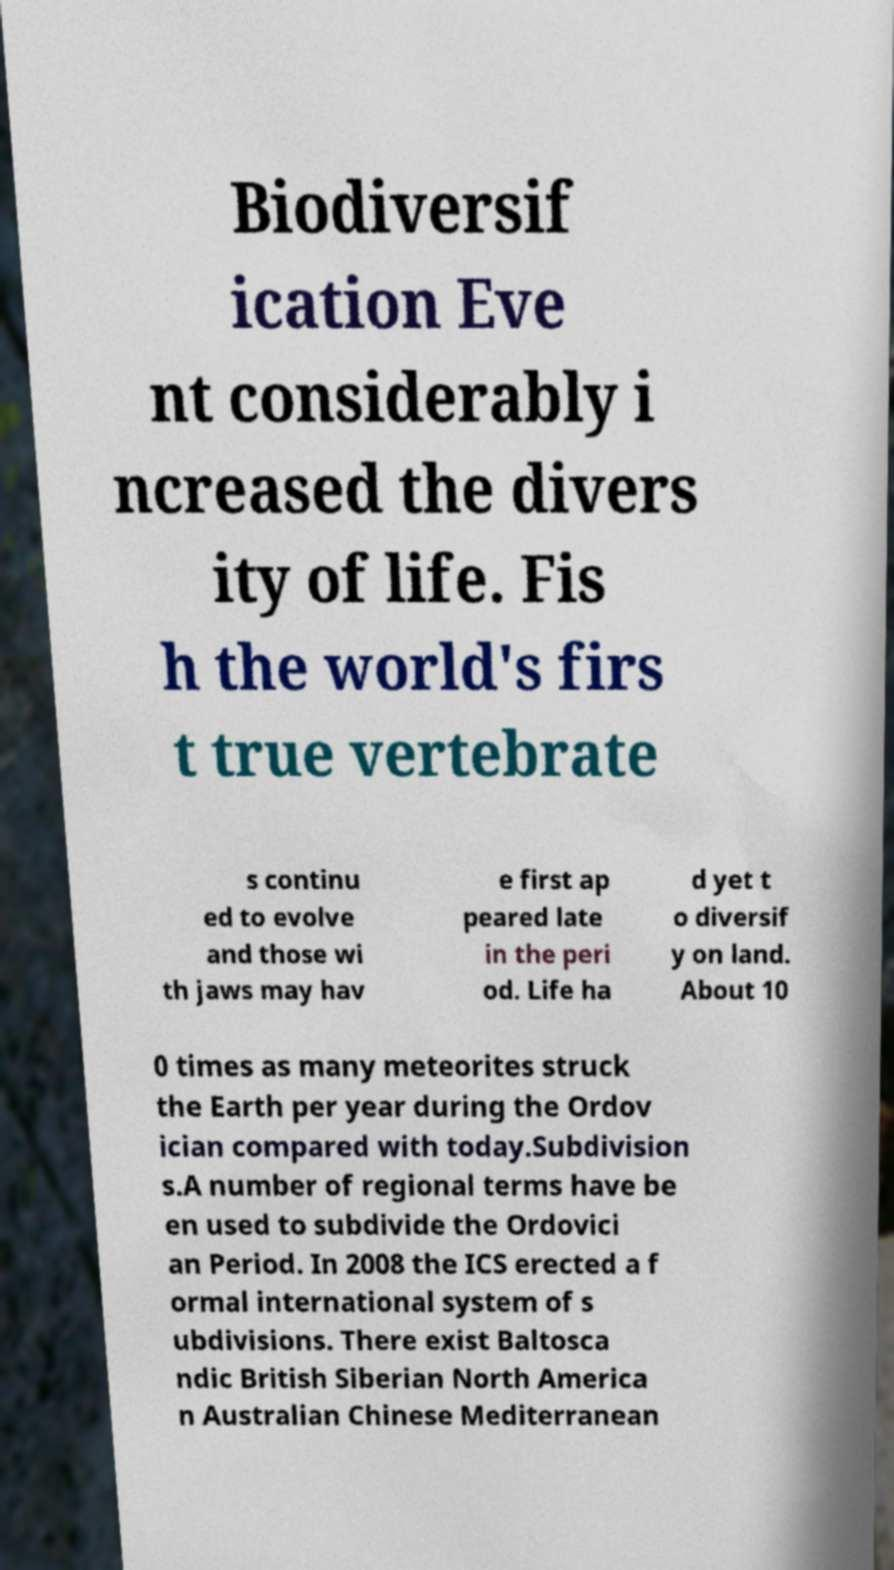Can you accurately transcribe the text from the provided image for me? Biodiversif ication Eve nt considerably i ncreased the divers ity of life. Fis h the world's firs t true vertebrate s continu ed to evolve and those wi th jaws may hav e first ap peared late in the peri od. Life ha d yet t o diversif y on land. About 10 0 times as many meteorites struck the Earth per year during the Ordov ician compared with today.Subdivision s.A number of regional terms have be en used to subdivide the Ordovici an Period. In 2008 the ICS erected a f ormal international system of s ubdivisions. There exist Baltosca ndic British Siberian North America n Australian Chinese Mediterranean 